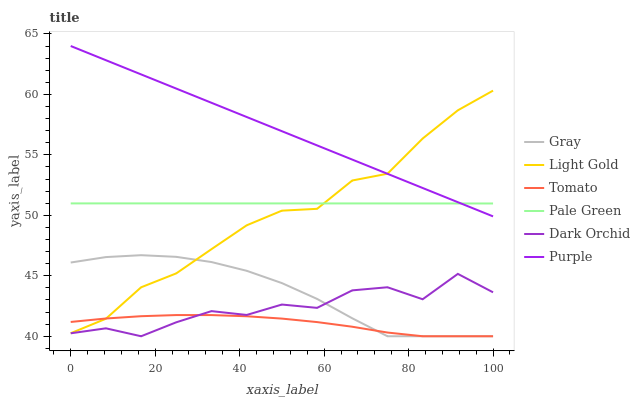Does Tomato have the minimum area under the curve?
Answer yes or no. Yes. Does Purple have the maximum area under the curve?
Answer yes or no. Yes. Does Gray have the minimum area under the curve?
Answer yes or no. No. Does Gray have the maximum area under the curve?
Answer yes or no. No. Is Purple the smoothest?
Answer yes or no. Yes. Is Dark Orchid the roughest?
Answer yes or no. Yes. Is Gray the smoothest?
Answer yes or no. No. Is Gray the roughest?
Answer yes or no. No. Does Tomato have the lowest value?
Answer yes or no. Yes. Does Purple have the lowest value?
Answer yes or no. No. Does Purple have the highest value?
Answer yes or no. Yes. Does Gray have the highest value?
Answer yes or no. No. Is Gray less than Pale Green?
Answer yes or no. Yes. Is Pale Green greater than Gray?
Answer yes or no. Yes. Does Light Gold intersect Pale Green?
Answer yes or no. Yes. Is Light Gold less than Pale Green?
Answer yes or no. No. Is Light Gold greater than Pale Green?
Answer yes or no. No. Does Gray intersect Pale Green?
Answer yes or no. No. 